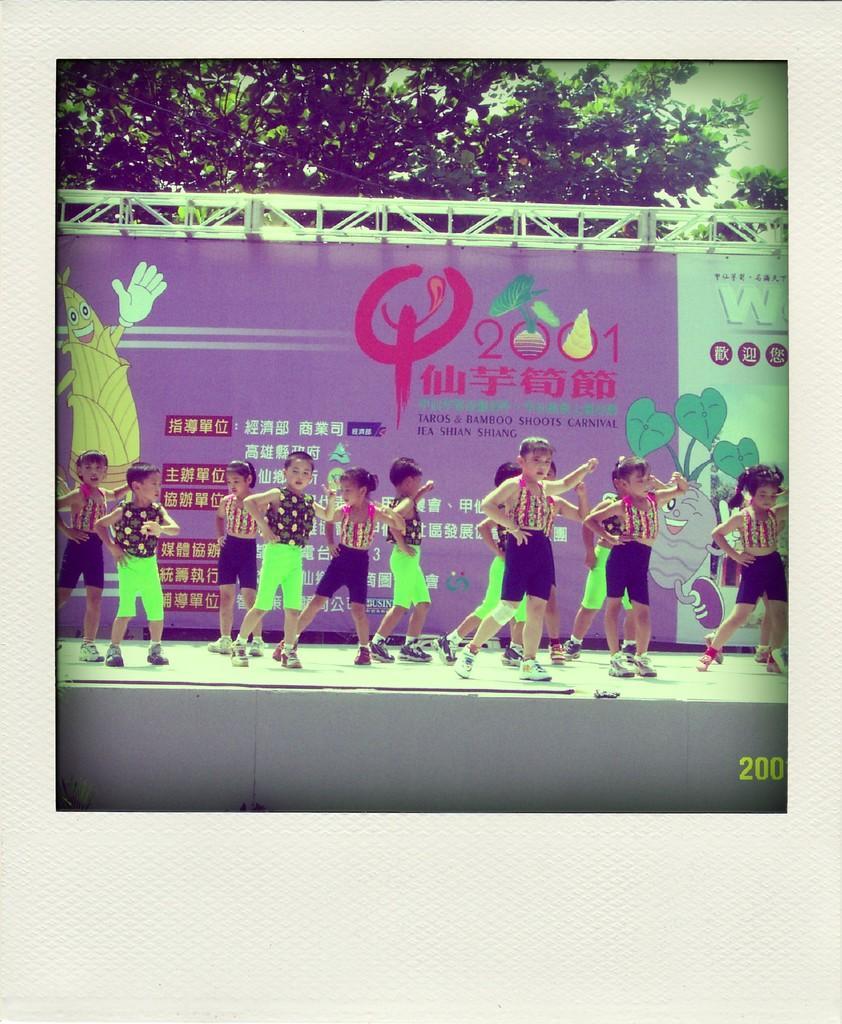Could you give a brief overview of what you see in this image? In this image I can see the group of people standing on the stage. These people are wearing the different color dresses. In the background I can see the banner which is colorful. I can also see the trees and sky in the back. 